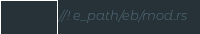<code> <loc_0><loc_0><loc_500><loc_500><_Rust_>//! e_path/eb/mod.rs
</code> 